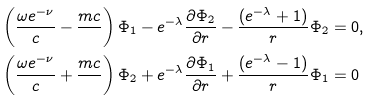<formula> <loc_0><loc_0><loc_500><loc_500>& \left ( \frac { \omega e ^ { - \nu } } { c } - \frac { m c } { } \right ) \Phi _ { 1 } - e ^ { - \lambda } \frac { \partial \Phi _ { 2 } } { \partial r } - \frac { ( e ^ { - \lambda } + 1 ) } { r } \Phi _ { 2 } = 0 , \\ & \left ( \frac { \omega e ^ { - \nu } } { c } + \frac { m c } { } \right ) \Phi _ { 2 } + e ^ { - \lambda } \frac { \partial \Phi _ { 1 } } { \partial r } + \frac { ( e ^ { - \lambda } - 1 ) } { r } \Phi _ { 1 } = 0</formula> 